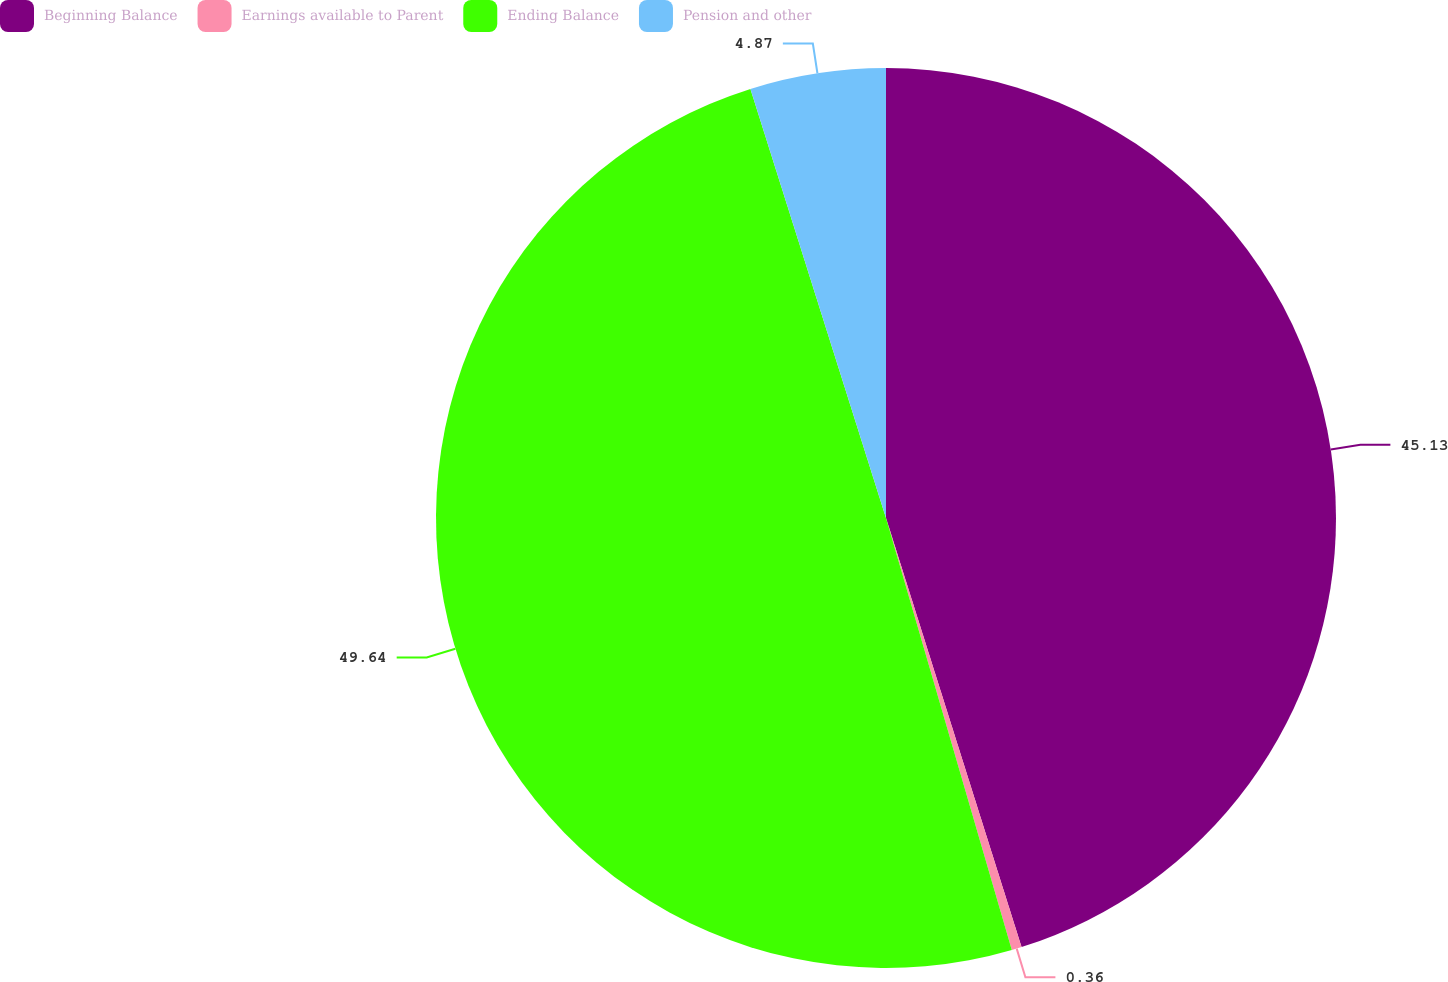<chart> <loc_0><loc_0><loc_500><loc_500><pie_chart><fcel>Beginning Balance<fcel>Earnings available to Parent<fcel>Ending Balance<fcel>Pension and other<nl><fcel>45.13%<fcel>0.36%<fcel>49.64%<fcel>4.87%<nl></chart> 